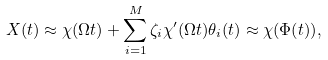<formula> <loc_0><loc_0><loc_500><loc_500>X ( t ) \approx \chi ( \Omega t ) + \sum _ { i = 1 } ^ { M } \zeta _ { i } \chi ^ { \prime } ( \Omega t ) \theta _ { i } ( t ) \approx \chi ( \Phi ( t ) ) ,</formula> 